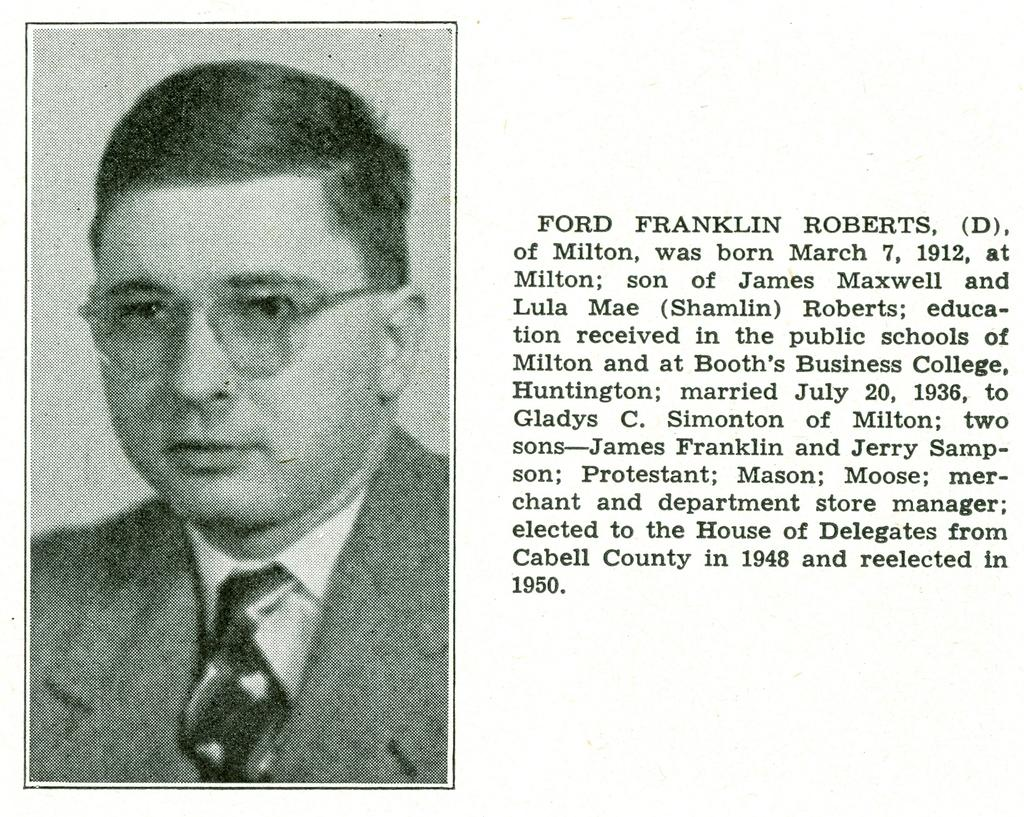What type of publication does the image come from? The image is from a magazine. What is the main subject of the image? There is a picture of a human in the image. What is the person in the image wearing? The person in the image is wearing a suit and glasses. Where can text be found in the image? There is text on the right side of the image. What type of information does the text provide? The text represents a biography. What type of lunch is the person in the image eating? There is no indication of the person eating lunch in the image. What type of lace can be seen on the person's clothing in the image? The person in the image is wearing a suit, which does not have lace. 